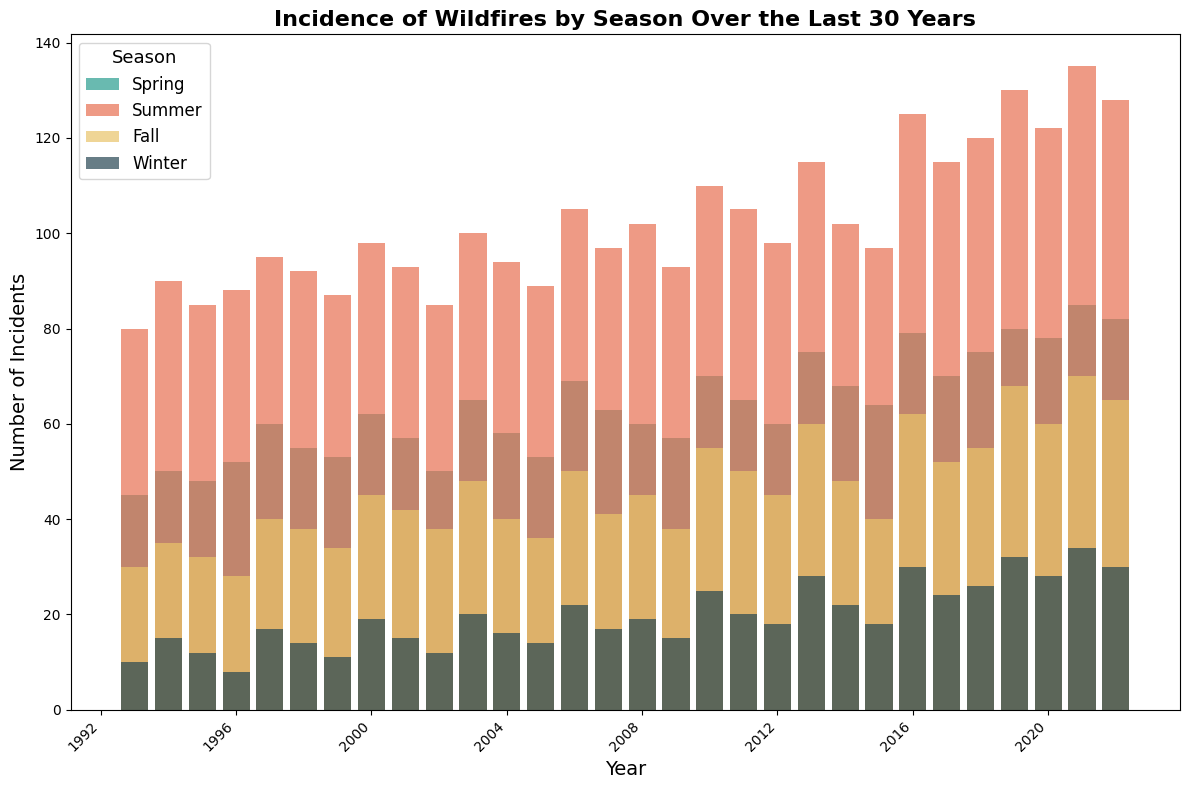What is the overall trend in the number of wildfire incidents in summer over the 30 years? Observing the height of the bars representing summer (red color) from 1993 to 2022, we can see a general upward trend in the number of incidences, indicating that summer wildfires have increased over the years.
Answer: Increasing Which season has the highest number of incidents in 2019 and how many incidents were there? By inspecting the bar heights for each season in 2019, summer (red bar) is the tallest, indicating the highest number of incidents. The number indicated by the y-axis is 130.
Answer: Summer, 130 In which year did winter have the fewest wildfire incidents, and what was the number? Looking at the winter bars (blue) throughout the years, 1996 appears to have the shortest bar. The number associated with it is 8.
Answer: 1996, 8 What is the difference in the number of wildfire incidents between spring and fall in 2021? The height of the spring bar (green) in 2021 indicates 85 incidents, while the height of the fall bar (yellow) indicates 70 incidents. The difference is 85 - 70.
Answer: 15 Which season shows the most significant increase in wildfire incidents from 1993 to 2022? Comparing the height of the bars for each season at two points, spring (green) and fall (yellow) show clear increases, but summer (red) shows the most significant increase from 80 in 1993 to 128 in 2022.
Answer: Summer What is the average number of wildfire incidents in winter across the entire 30-year period? To find the average, sum the values for winter across all years and divide by 30. The total sum of winter incidents is (10 + 15 + 12 + 8 + 17 + 14 + 11 + 19 + 15 + 20 + 16 + 14 + 22 + 17 + 19 + 15 + 25 + 20 + 18 + 28 + 22 + 18 + 30 + 24 + 26 + 32 + 28 + 34 + 30) = 540. Now dividing this by 30 gives 540 / 30.
Answer: 18 Between which consecutive years did summer fire incidents increase the most? By inspecting the heights of the summer bars (red) across consecutive years, we see the biggest jump between 2015 (97) and 2016 (125) which is an increase of 28.
Answer: Between 2015 and 2016 How many more incidents were there in fall compared to spring in 2016? The bar for fall (yellow) in 2016 indicates 62 incidents, while the bar for spring (green) indicates 79 incidents. The difference is 62 - 79.
Answer: -17 (17 fewer in fall) What percentage of the total incidents in 2013 occurred in the summer? In 2013, the total incidents are Spring (75) + Summer (115) + Fall (60) + Winter (28) = 278. Summer incidents are 115. The percentage is (115 / 278) * 100.
Answer: 41.37% Which year had the highest total number of wildfire incidents across all seasons, and what was the total? By adding up the incidents for each year for all seasons, 2021 has the highest with Spring (85) + Summer (135) + Fall (70) + Winter (34) = 324.
Answer: 2021, 324 